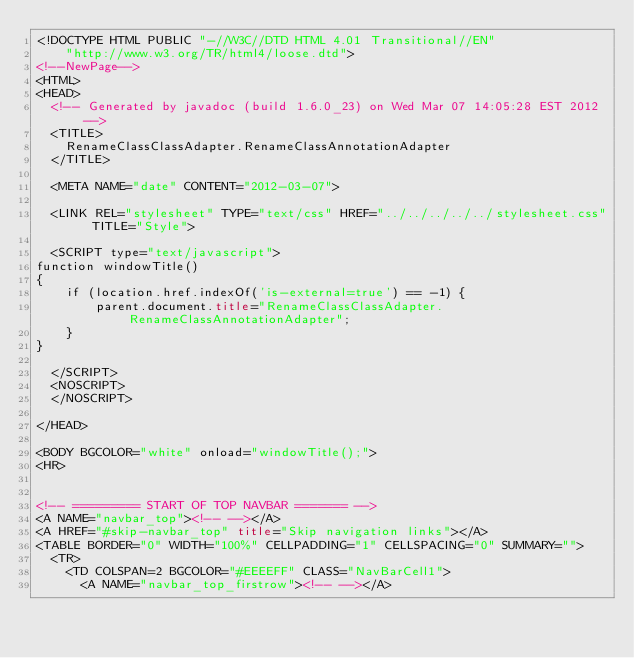Convert code to text. <code><loc_0><loc_0><loc_500><loc_500><_HTML_><!DOCTYPE HTML PUBLIC "-//W3C//DTD HTML 4.01 Transitional//EN"
    "http://www.w3.org/TR/html4/loose.dtd">
<!--NewPage-->
<HTML>
<HEAD>
  <!-- Generated by javadoc (build 1.6.0_23) on Wed Mar 07 14:05:28 EST 2012 -->
  <TITLE>
    RenameClassClassAdapter.RenameClassAnnotationAdapter
  </TITLE>

  <META NAME="date" CONTENT="2012-03-07">

  <LINK REL="stylesheet" TYPE="text/css" HREF="../../../../../stylesheet.css" TITLE="Style">

  <SCRIPT type="text/javascript">
function windowTitle()
{
    if (location.href.indexOf('is-external=true') == -1) {
        parent.document.title="RenameClassClassAdapter.RenameClassAnnotationAdapter";
    }
}

  </SCRIPT>
  <NOSCRIPT>
  </NOSCRIPT>

</HEAD>

<BODY BGCOLOR="white" onload="windowTitle();">
<HR>


<!-- ========= START OF TOP NAVBAR ======= -->
<A NAME="navbar_top"><!-- --></A>
<A HREF="#skip-navbar_top" title="Skip navigation links"></A>
<TABLE BORDER="0" WIDTH="100%" CELLPADDING="1" CELLSPACING="0" SUMMARY="">
  <TR>
    <TD COLSPAN=2 BGCOLOR="#EEEEFF" CLASS="NavBarCell1">
      <A NAME="navbar_top_firstrow"><!-- --></A></code> 